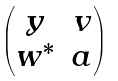Convert formula to latex. <formula><loc_0><loc_0><loc_500><loc_500>\begin{pmatrix} y & v \\ w ^ { * } & a \\ \end{pmatrix}</formula> 